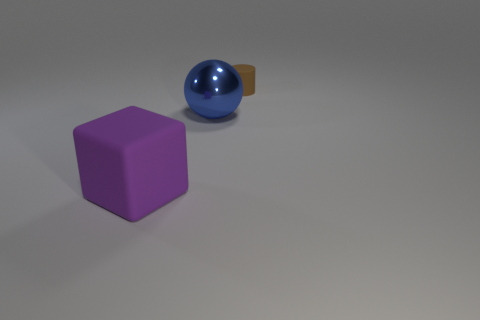Can you tell me what objects are present in this image? There are three objects in this image: a large matte purple cube on the left, a shiny blue sphere in the center, and a small yellow cylindrical object partially hidden behind the sphere. 